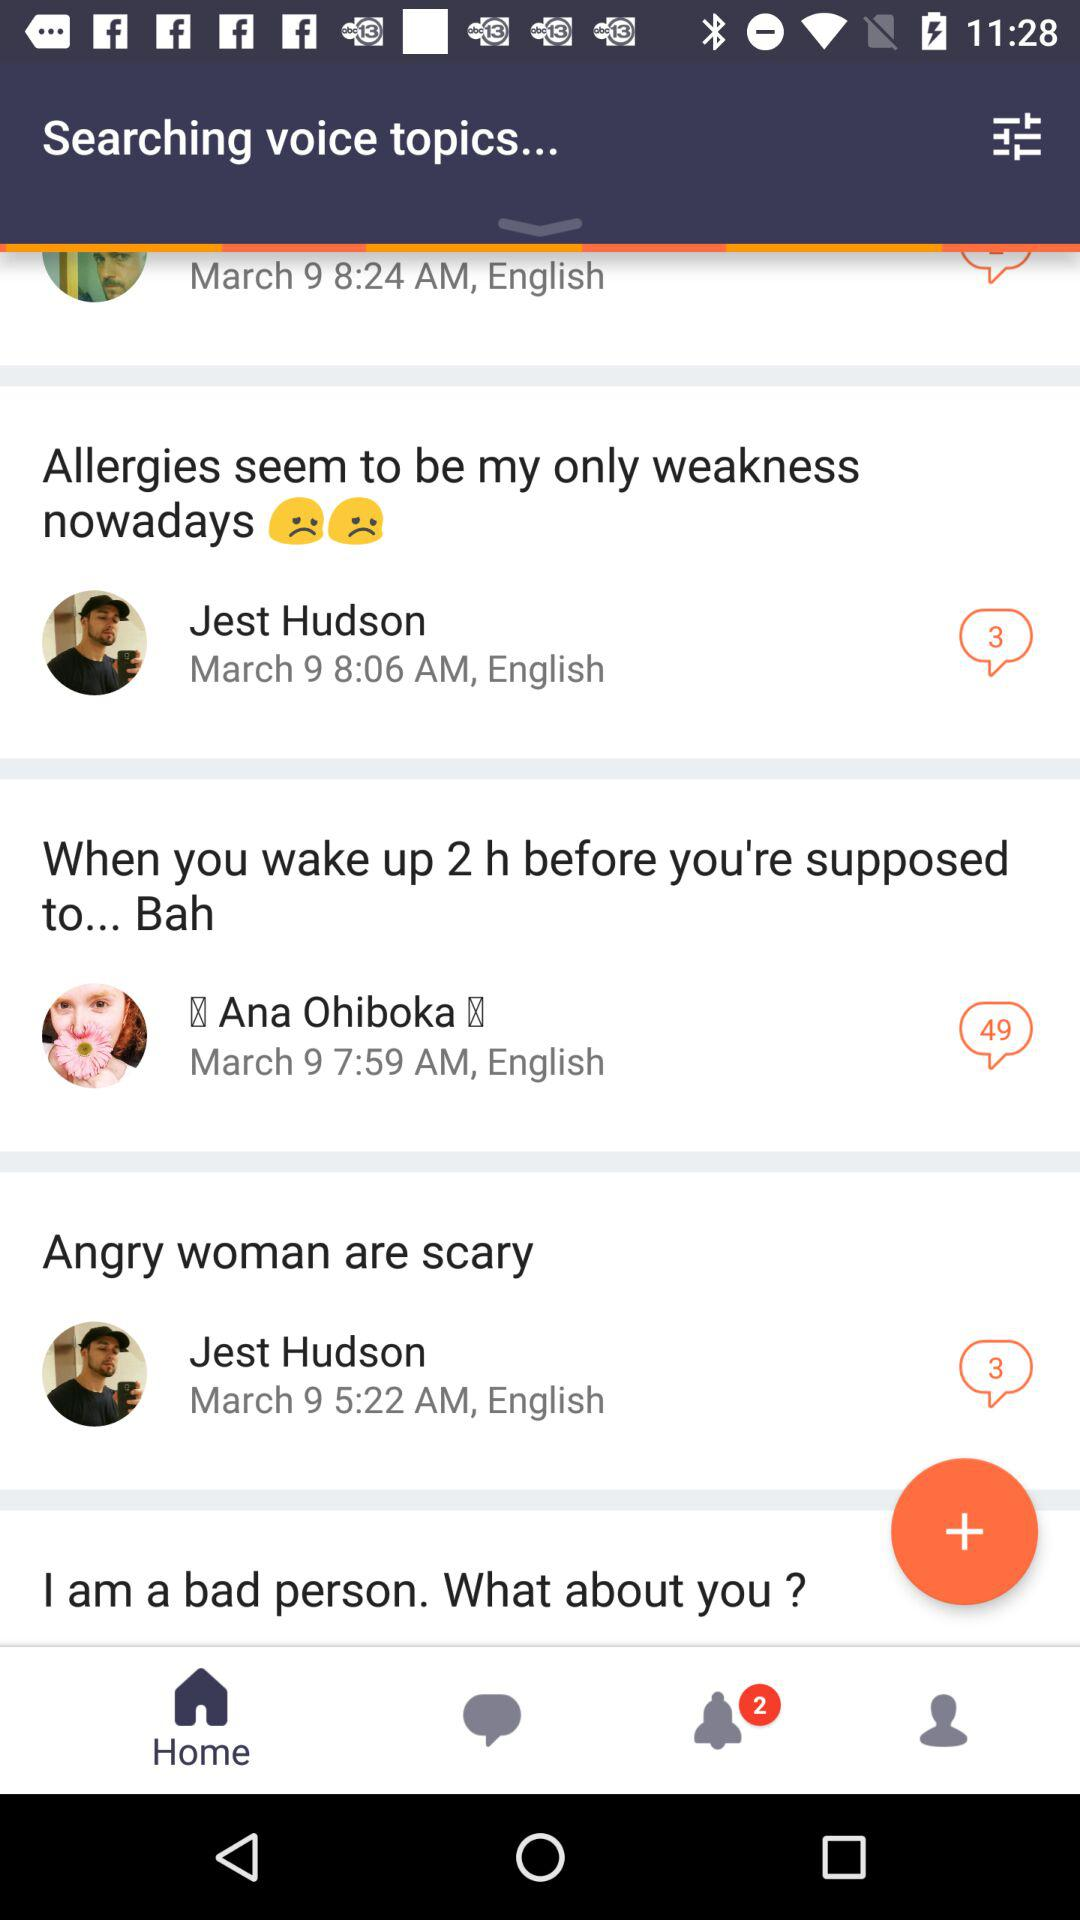At which time did Ana Ohiboka post her comment? The time is 7:59 AM. 